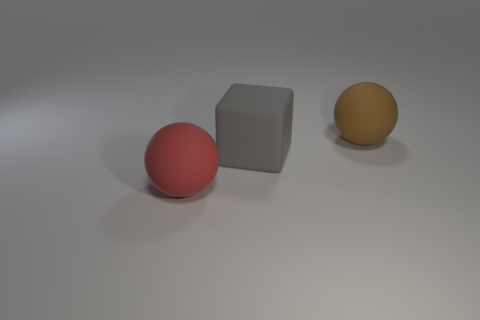There is a block that is the same size as the red object; what is its material?
Your response must be concise. Rubber. Are there fewer large red spheres to the right of the cube than big blocks that are in front of the brown object?
Your answer should be compact. Yes. How many brown rubber objects have the same shape as the red object?
Make the answer very short. 1. What is the color of the big rubber ball that is to the right of the big matte ball that is to the left of the brown rubber ball?
Make the answer very short. Brown. There is a red thing; is it the same shape as the big object behind the block?
Ensure brevity in your answer.  Yes. How many blocks are the same size as the brown rubber object?
Ensure brevity in your answer.  1. What material is the brown object that is the same shape as the red matte object?
Your answer should be very brief. Rubber. What shape is the large object that is left of the big gray object?
Offer a very short reply. Sphere. What color is the matte cube?
Offer a terse response. Gray. There is a gray object that is the same material as the big red sphere; what is its shape?
Offer a terse response. Cube. 